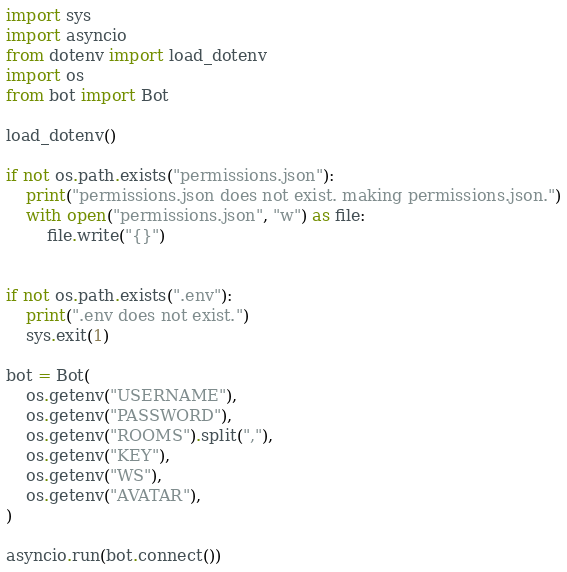Convert code to text. <code><loc_0><loc_0><loc_500><loc_500><_Python_>import sys
import asyncio
from dotenv import load_dotenv
import os
from bot import Bot

load_dotenv()

if not os.path.exists("permissions.json"):
    print("permissions.json does not exist. making permissions.json.")
    with open("permissions.json", "w") as file:
        file.write("{}")


if not os.path.exists(".env"):
    print(".env does not exist.")
    sys.exit(1)

bot = Bot(
    os.getenv("USERNAME"),
    os.getenv("PASSWORD"),
    os.getenv("ROOMS").split(","),
    os.getenv("KEY"),
    os.getenv("WS"),
    os.getenv("AVATAR"),
)

asyncio.run(bot.connect())
</code> 